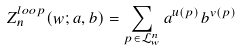Convert formula to latex. <formula><loc_0><loc_0><loc_500><loc_500>Z _ { n } ^ { l o o p } ( w ; a , b ) = \sum _ { p \in \mathcal { L } _ { w } ^ { n } } a ^ { u ( p ) } b ^ { v ( p ) }</formula> 